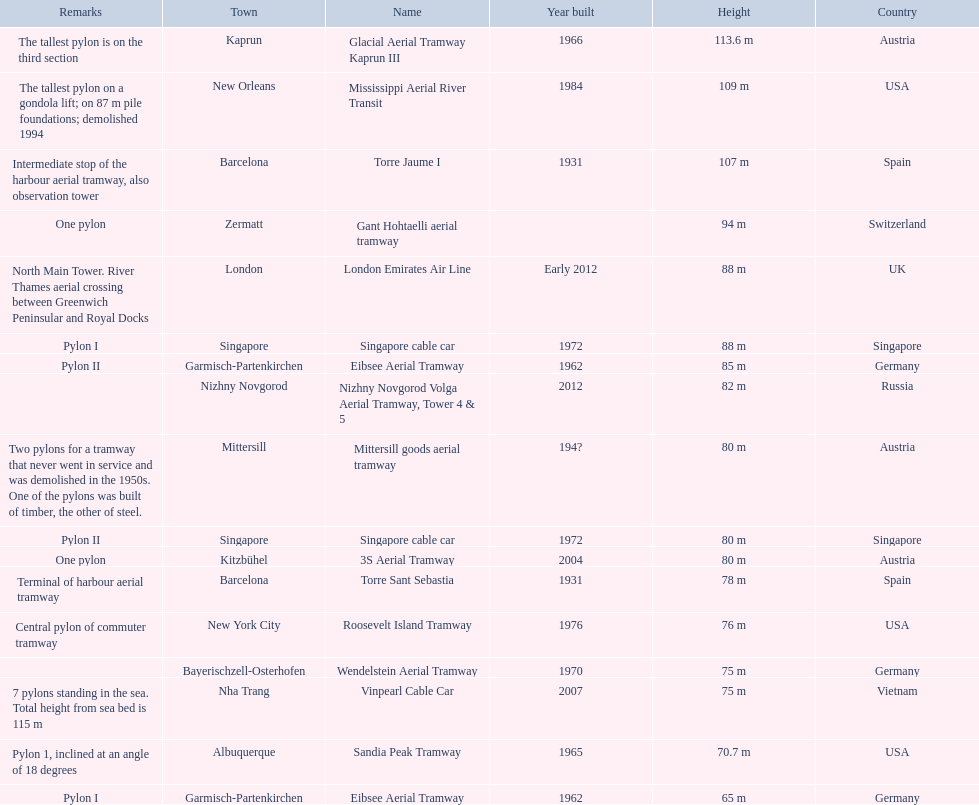Which lift has the second highest height? Mississippi Aerial River Transit. Would you be able to parse every entry in this table? {'header': ['Remarks', 'Town', 'Name', 'Year built', 'Height', 'Country'], 'rows': [['The tallest pylon is on the third section', 'Kaprun', 'Glacial Aerial Tramway Kaprun III', '1966', '113.6 m', 'Austria'], ['The tallest pylon on a gondola lift; on 87 m pile foundations; demolished 1994', 'New Orleans', 'Mississippi Aerial River Transit', '1984', '109 m', 'USA'], ['Intermediate stop of the harbour aerial tramway, also observation tower', 'Barcelona', 'Torre Jaume I', '1931', '107 m', 'Spain'], ['One pylon', 'Zermatt', 'Gant Hohtaelli aerial tramway', '', '94 m', 'Switzerland'], ['North Main Tower. River Thames aerial crossing between Greenwich Peninsular and Royal Docks', 'London', 'London Emirates Air Line', 'Early 2012', '88 m', 'UK'], ['Pylon I', 'Singapore', 'Singapore cable car', '1972', '88 m', 'Singapore'], ['Pylon II', 'Garmisch-Partenkirchen', 'Eibsee Aerial Tramway', '1962', '85 m', 'Germany'], ['', 'Nizhny Novgorod', 'Nizhny Novgorod Volga Aerial Tramway, Tower 4 & 5', '2012', '82 m', 'Russia'], ['Two pylons for a tramway that never went in service and was demolished in the 1950s. One of the pylons was built of timber, the other of steel.', 'Mittersill', 'Mittersill goods aerial tramway', '194?', '80 m', 'Austria'], ['Pylon II', 'Singapore', 'Singapore cable car', '1972', '80 m', 'Singapore'], ['One pylon', 'Kitzbühel', '3S Aerial Tramway', '2004', '80 m', 'Austria'], ['Terminal of harbour aerial tramway', 'Barcelona', 'Torre Sant Sebastia', '1931', '78 m', 'Spain'], ['Central pylon of commuter tramway', 'New York City', 'Roosevelt Island Tramway', '1976', '76 m', 'USA'], ['', 'Bayerischzell-Osterhofen', 'Wendelstein Aerial Tramway', '1970', '75 m', 'Germany'], ['7 pylons standing in the sea. Total height from sea bed is 115 m', 'Nha Trang', 'Vinpearl Cable Car', '2007', '75 m', 'Vietnam'], ['Pylon 1, inclined at an angle of 18 degrees', 'Albuquerque', 'Sandia Peak Tramway', '1965', '70.7 m', 'USA'], ['Pylon I', 'Garmisch-Partenkirchen', 'Eibsee Aerial Tramway', '1962', '65 m', 'Germany']]} What is the value of the height? 109 m. 